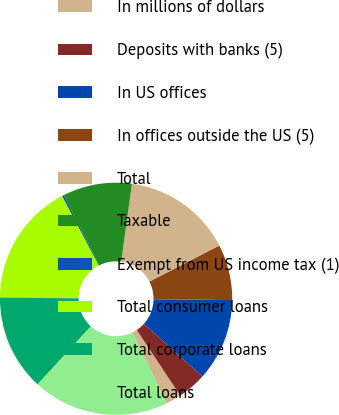<chart> <loc_0><loc_0><loc_500><loc_500><pie_chart><fcel>In millions of dollars<fcel>Deposits with banks (5)<fcel>In US offices<fcel>In offices outside the US (5)<fcel>Total<fcel>Taxable<fcel>Exempt from US income tax (1)<fcel>Total consumer loans<fcel>Total corporate loans<fcel>Total loans<nl><fcel>2.14%<fcel>4.01%<fcel>11.5%<fcel>7.76%<fcel>15.24%<fcel>9.63%<fcel>0.27%<fcel>17.11%<fcel>13.37%<fcel>18.98%<nl></chart> 